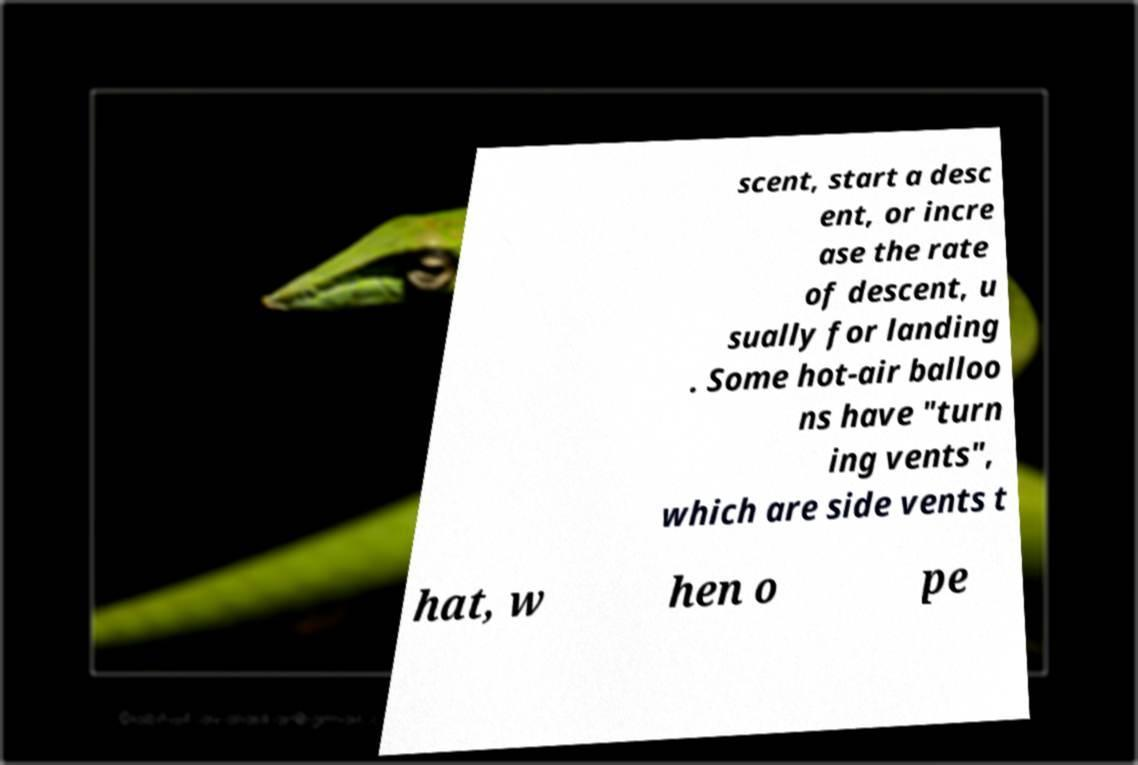There's text embedded in this image that I need extracted. Can you transcribe it verbatim? scent, start a desc ent, or incre ase the rate of descent, u sually for landing . Some hot-air balloo ns have "turn ing vents", which are side vents t hat, w hen o pe 